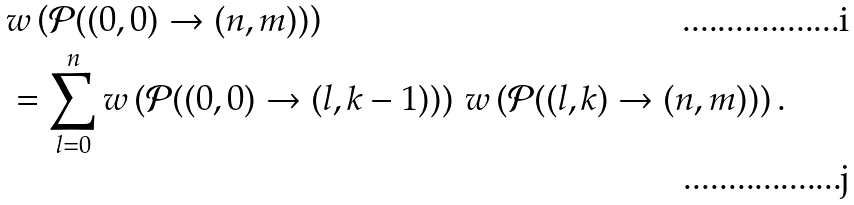Convert formula to latex. <formula><loc_0><loc_0><loc_500><loc_500>& w \left ( \mathcal { P } ( ( 0 , 0 ) \to ( n , m ) ) \right ) \\ & = \sum _ { l = 0 } ^ { n } w \left ( \mathcal { P } ( ( 0 , 0 ) \to ( l , k - 1 ) ) \right ) \, w \left ( \mathcal { P } ( ( l , k ) \to ( n , m ) ) \right ) .</formula> 